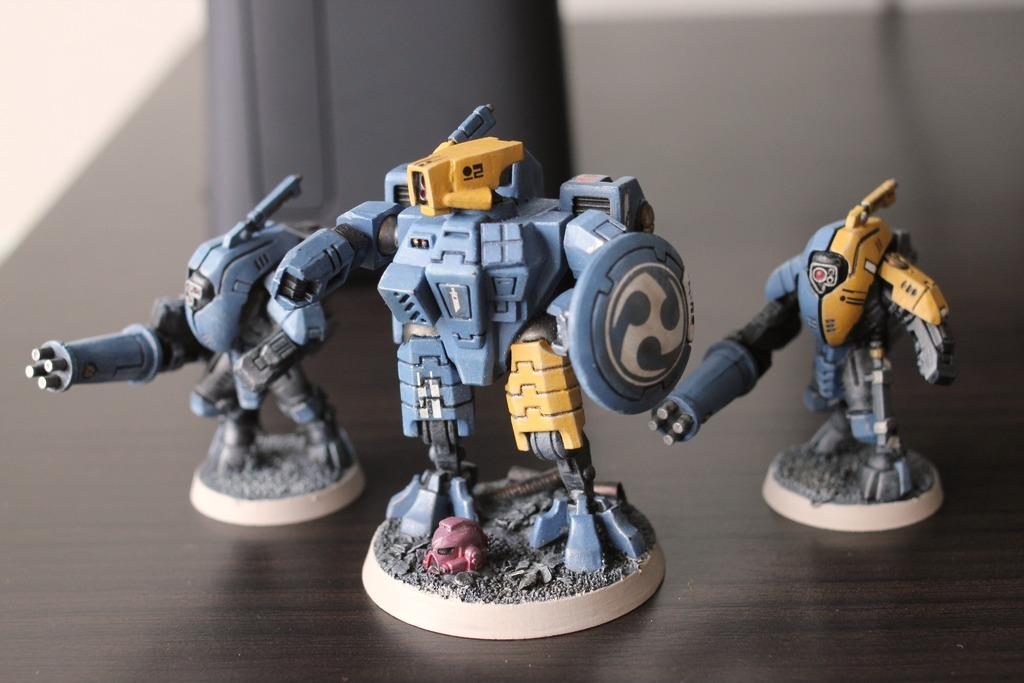What can be seen in the image that children might play with? There are toys in the image that children might play with. What is the object on a platform in the image? The facts do not specify the object on the platform, so we cannot answer this question definitively. How would you describe the background of the image? The background of the image is blurred. What route do the giants take to reach the toys in the image? There are no giants present in the image, so there is no route for them to reach the toys. 